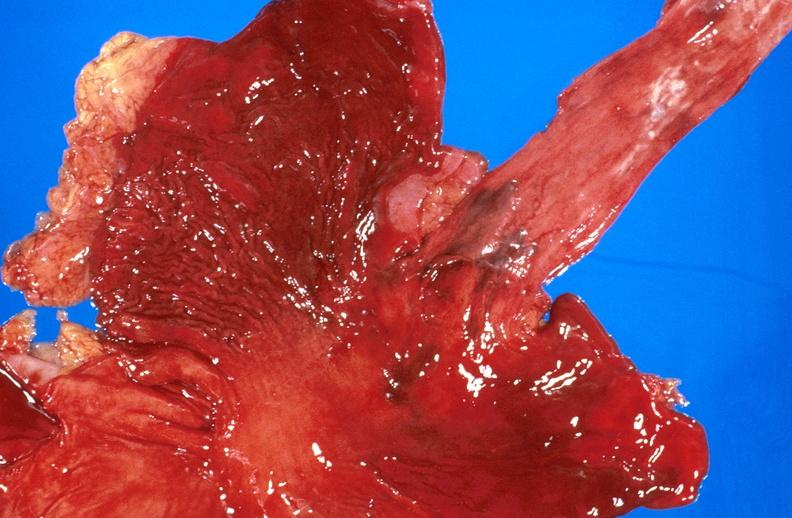does atherosclerosis show esophageal varices due to alcoholic cirrhosis?
Answer the question using a single word or phrase. No 